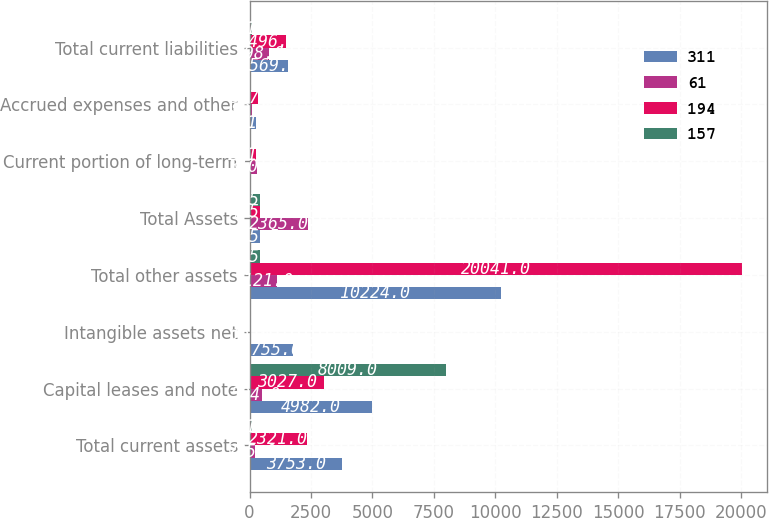Convert chart. <chart><loc_0><loc_0><loc_500><loc_500><stacked_bar_chart><ecel><fcel>Total current assets<fcel>Capital leases and note<fcel>Intangible assets net<fcel>Total other assets<fcel>Total Assets<fcel>Current portion of long-term<fcel>Accrued expenses and other<fcel>Total current liabilities<nl><fcel>311<fcel>3753<fcel>4982<fcel>1755<fcel>10224<fcel>425.5<fcel>58<fcel>261<fcel>1569<nl><fcel>61<fcel>235<fcel>504<fcel>20<fcel>1121<fcel>2365<fcel>310<fcel>82<fcel>798<nl><fcel>194<fcel>2321<fcel>3027<fcel>33<fcel>20041<fcel>425.5<fcel>261<fcel>347<fcel>1496<nl><fcel>157<fcel>101<fcel>8009<fcel>31<fcel>425.5<fcel>425.5<fcel>58<fcel>43<fcel>101<nl></chart> 